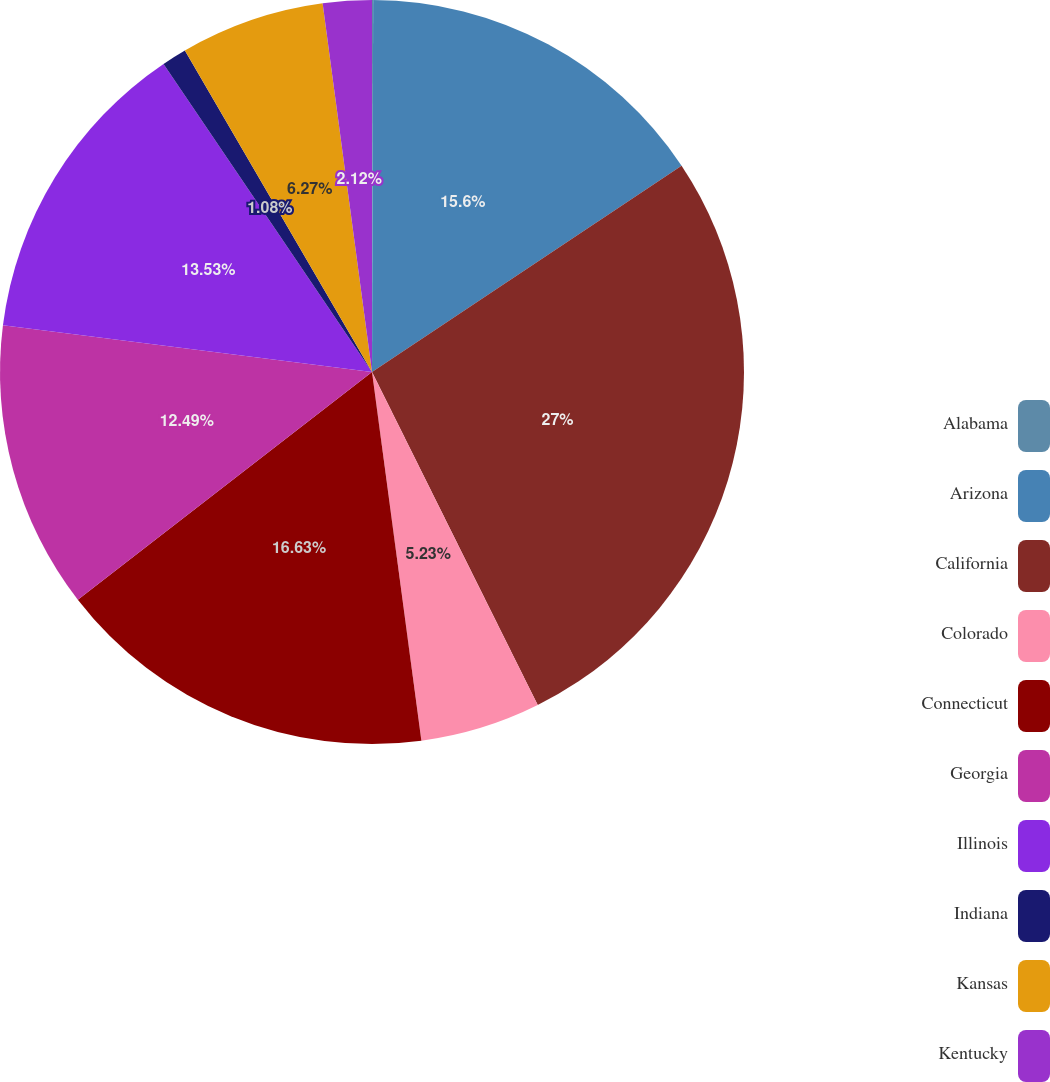Convert chart. <chart><loc_0><loc_0><loc_500><loc_500><pie_chart><fcel>Alabama<fcel>Arizona<fcel>California<fcel>Colorado<fcel>Connecticut<fcel>Georgia<fcel>Illinois<fcel>Indiana<fcel>Kansas<fcel>Kentucky<nl><fcel>0.05%<fcel>15.6%<fcel>27.01%<fcel>5.23%<fcel>16.64%<fcel>12.49%<fcel>13.53%<fcel>1.08%<fcel>6.27%<fcel>2.12%<nl></chart> 